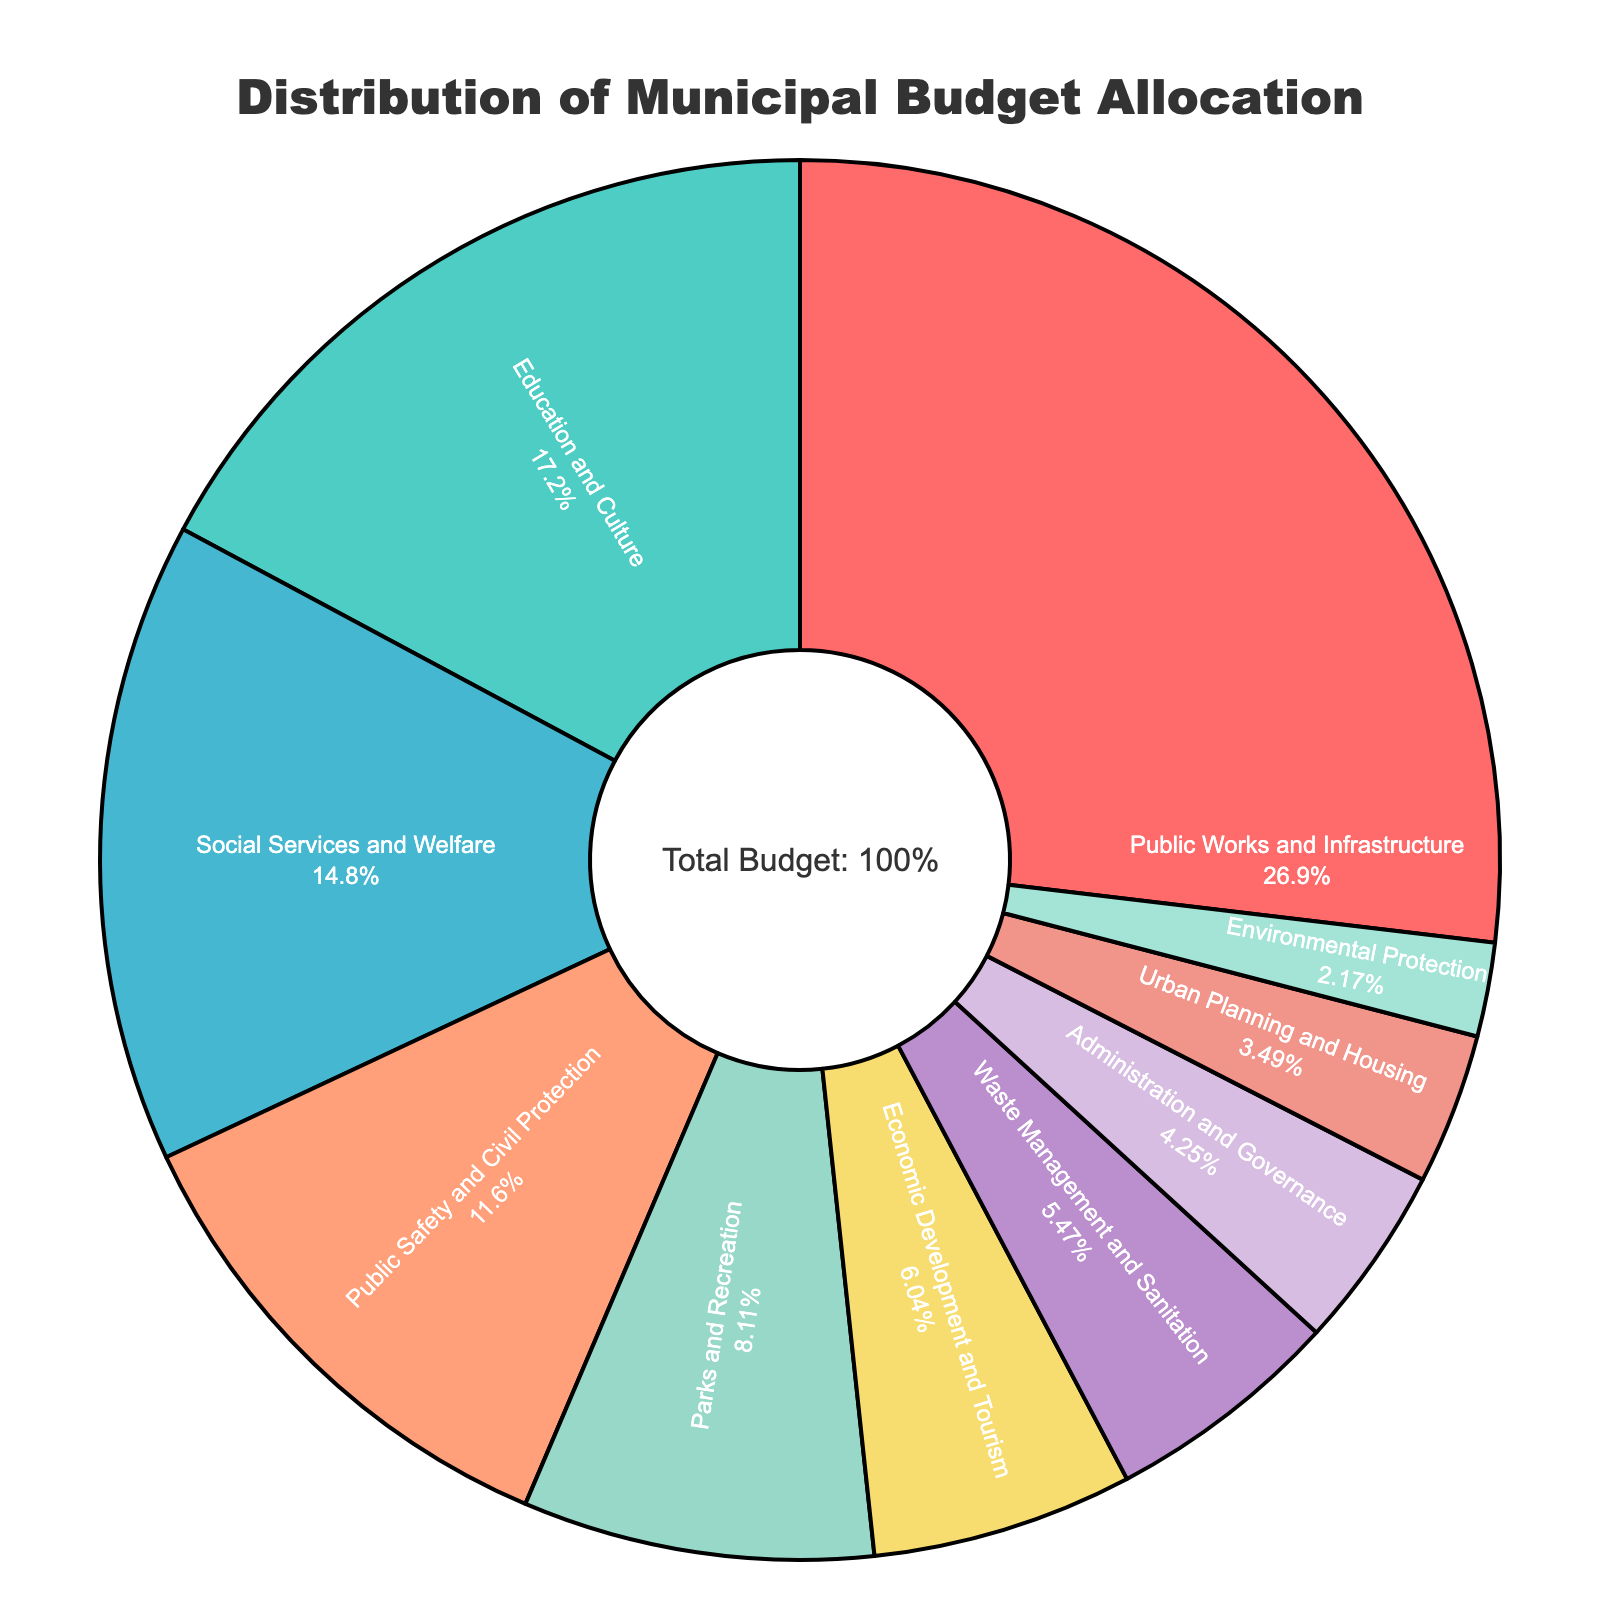Which sector receives the highest percentage of the budget allocation? The pie chart shows that Public Works and Infrastructure has the largest slice.
Answer: Public Works and Infrastructure Which two sectors combined have a percentage just over 30%? The sectors Economic Development and Tourism (6.4%) and Waste Management and Sanitation (5.8%) combined equals 12.2%. The percentage over 30% would be Public Safety and Civil Protection (12.3%) combined with Parks and Recreation (8.6%) equals 20.9%. Another combined combination of figures would be Administration and Governance (4.5%) and Urban Planning and Housing (3.7%) equal to 8.2%.
Answer: Public Works and Infrastructure and Education and Culture What is the combined budget allocation for Social Services and Welfare and Public Safety and Civil Protection? Adding the percentage for Social Services and Welfare (15.7%) and Public Safety and Civil Protection (12.3%) gives 15.7 + 12.3 = 28%.
Answer: 28% How much more percentage of the budget is allocated to Education and Culture compared to Urban Planning and Housing? Subtracting the percentage allocation for Urban Planning and Housing (3.7%) from Education and Culture (18.2%) gives 18.2 - 3.7 = 14.5%.
Answer: 14.5% What percentage of the budget is allocated to sectors other than Public Works and Infrastructure? Subtracting the percentage for Public Works and Infrastructure (28.5%) from 100% gives 100 - 28.5 = 71.5%.
Answer: 71.5% Which sector has the smallest budget allocation, and what is its percentage? The sector with the smallest slice in the pie chart indicates the smallest allocation.
Answer: Environmental Protection, 2.3% Compare the budget allocated to Waste Management and Sanitation with the budget allocated to Economic Development and Tourism. Which one is higher and by how much? Waste Management and Sanitation has 5.8% while Economic Development and Tourism has 6.4%. Subtracting the two gives 6.4 - 5.8 = 0.6%.
Answer: Economic Development and Tourism, by 0.6% If we grouped Social Services and Welfare, Administration and Governance, and Urban Planning and Housing together, what would be their combined budget allocation? Adding their respective percentages 15.7% (Social Services and Welfare) + 4.5% (Administration and Governance) + 3.7% (Urban Planning and Housing) gives 15.7 + 4.5 + 3.7 = 23.9%.
Answer: 23.9% What is the difference in budget allocation between Parks and Recreation and Public Safety and Civil Protection? Subtracting Parks and Recreation's percentage (8.6%) from Public Safety and Civil Protection's percentage (12.3%) gives 12.3 - 8.6 = 3.7%.
Answer: 3.7% What percentage of the budget is allocated to Education and Culture compared to Social Services and Welfare? The percentage for Education and Culture is 18.2% while for Social Services and Welfare it is 15.7%. The comparison shows that Education and Culture has a higher percentage by 2.5% (18.2 - 15.7 = 2.5).
Answer: 2.5% more 